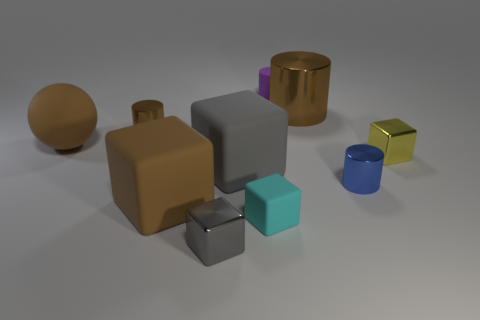Subtract all cyan blocks. How many blocks are left? 4 Subtract 2 blocks. How many blocks are left? 3 Subtract all tiny yellow metallic cubes. How many cubes are left? 4 Subtract all blue cubes. Subtract all brown spheres. How many cubes are left? 5 Subtract all spheres. How many objects are left? 9 Add 9 gray shiny blocks. How many gray shiny blocks are left? 10 Add 5 brown cylinders. How many brown cylinders exist? 7 Subtract 0 cyan cylinders. How many objects are left? 10 Subtract all cyan rubber things. Subtract all gray matte objects. How many objects are left? 8 